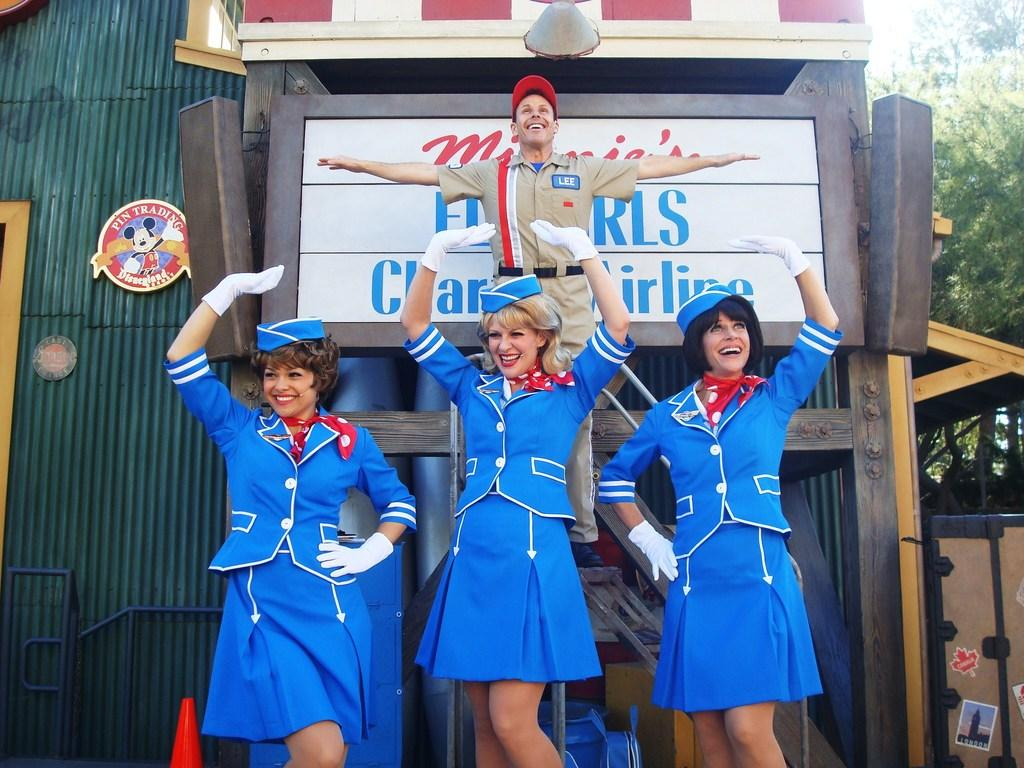<image>
Provide a brief description of the given image. The Mickey Mouse sign on the wall says "Pin Trading Disneyland Resort" 